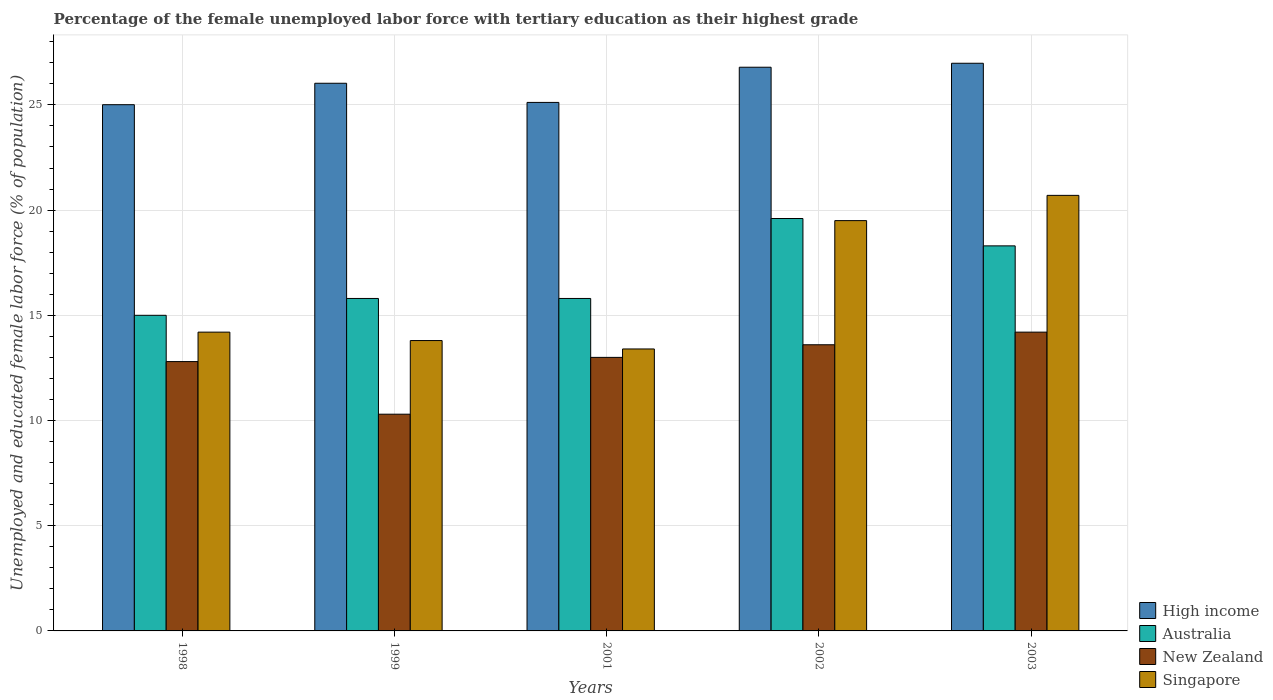Are the number of bars per tick equal to the number of legend labels?
Keep it short and to the point. Yes. Are the number of bars on each tick of the X-axis equal?
Make the answer very short. Yes. What is the label of the 2nd group of bars from the left?
Offer a very short reply. 1999. What is the percentage of the unemployed female labor force with tertiary education in New Zealand in 2003?
Offer a terse response. 14.2. Across all years, what is the maximum percentage of the unemployed female labor force with tertiary education in Australia?
Provide a succinct answer. 19.6. Across all years, what is the minimum percentage of the unemployed female labor force with tertiary education in Singapore?
Offer a terse response. 13.4. What is the total percentage of the unemployed female labor force with tertiary education in Australia in the graph?
Keep it short and to the point. 84.5. What is the difference between the percentage of the unemployed female labor force with tertiary education in Singapore in 2002 and that in 2003?
Provide a short and direct response. -1.2. What is the difference between the percentage of the unemployed female labor force with tertiary education in Singapore in 1998 and the percentage of the unemployed female labor force with tertiary education in High income in 2001?
Your answer should be very brief. -10.92. What is the average percentage of the unemployed female labor force with tertiary education in High income per year?
Offer a very short reply. 25.98. In the year 1998, what is the difference between the percentage of the unemployed female labor force with tertiary education in High income and percentage of the unemployed female labor force with tertiary education in Australia?
Offer a very short reply. 10.01. What is the ratio of the percentage of the unemployed female labor force with tertiary education in Singapore in 1998 to that in 2001?
Keep it short and to the point. 1.06. What is the difference between the highest and the second highest percentage of the unemployed female labor force with tertiary education in Singapore?
Give a very brief answer. 1.2. What is the difference between the highest and the lowest percentage of the unemployed female labor force with tertiary education in High income?
Ensure brevity in your answer.  1.97. What does the 1st bar from the left in 2001 represents?
Your response must be concise. High income. What does the 1st bar from the right in 1999 represents?
Provide a short and direct response. Singapore. Are all the bars in the graph horizontal?
Your response must be concise. No. Does the graph contain any zero values?
Give a very brief answer. No. Where does the legend appear in the graph?
Provide a short and direct response. Bottom right. What is the title of the graph?
Offer a terse response. Percentage of the female unemployed labor force with tertiary education as their highest grade. What is the label or title of the Y-axis?
Provide a short and direct response. Unemployed and educated female labor force (% of population). What is the Unemployed and educated female labor force (% of population) of High income in 1998?
Provide a succinct answer. 25.01. What is the Unemployed and educated female labor force (% of population) in Australia in 1998?
Offer a very short reply. 15. What is the Unemployed and educated female labor force (% of population) of New Zealand in 1998?
Offer a terse response. 12.8. What is the Unemployed and educated female labor force (% of population) of Singapore in 1998?
Give a very brief answer. 14.2. What is the Unemployed and educated female labor force (% of population) in High income in 1999?
Offer a very short reply. 26.03. What is the Unemployed and educated female labor force (% of population) of Australia in 1999?
Provide a succinct answer. 15.8. What is the Unemployed and educated female labor force (% of population) of New Zealand in 1999?
Provide a succinct answer. 10.3. What is the Unemployed and educated female labor force (% of population) of Singapore in 1999?
Give a very brief answer. 13.8. What is the Unemployed and educated female labor force (% of population) of High income in 2001?
Your answer should be compact. 25.12. What is the Unemployed and educated female labor force (% of population) in Australia in 2001?
Give a very brief answer. 15.8. What is the Unemployed and educated female labor force (% of population) in New Zealand in 2001?
Your answer should be very brief. 13. What is the Unemployed and educated female labor force (% of population) of Singapore in 2001?
Keep it short and to the point. 13.4. What is the Unemployed and educated female labor force (% of population) in High income in 2002?
Your answer should be very brief. 26.79. What is the Unemployed and educated female labor force (% of population) in Australia in 2002?
Your answer should be very brief. 19.6. What is the Unemployed and educated female labor force (% of population) in New Zealand in 2002?
Provide a short and direct response. 13.6. What is the Unemployed and educated female labor force (% of population) of Singapore in 2002?
Give a very brief answer. 19.5. What is the Unemployed and educated female labor force (% of population) in High income in 2003?
Give a very brief answer. 26.98. What is the Unemployed and educated female labor force (% of population) of Australia in 2003?
Provide a succinct answer. 18.3. What is the Unemployed and educated female labor force (% of population) of New Zealand in 2003?
Give a very brief answer. 14.2. What is the Unemployed and educated female labor force (% of population) in Singapore in 2003?
Your answer should be compact. 20.7. Across all years, what is the maximum Unemployed and educated female labor force (% of population) in High income?
Your response must be concise. 26.98. Across all years, what is the maximum Unemployed and educated female labor force (% of population) of Australia?
Provide a short and direct response. 19.6. Across all years, what is the maximum Unemployed and educated female labor force (% of population) in New Zealand?
Ensure brevity in your answer.  14.2. Across all years, what is the maximum Unemployed and educated female labor force (% of population) of Singapore?
Give a very brief answer. 20.7. Across all years, what is the minimum Unemployed and educated female labor force (% of population) of High income?
Your answer should be compact. 25.01. Across all years, what is the minimum Unemployed and educated female labor force (% of population) in Australia?
Offer a terse response. 15. Across all years, what is the minimum Unemployed and educated female labor force (% of population) in New Zealand?
Keep it short and to the point. 10.3. Across all years, what is the minimum Unemployed and educated female labor force (% of population) of Singapore?
Provide a succinct answer. 13.4. What is the total Unemployed and educated female labor force (% of population) in High income in the graph?
Provide a succinct answer. 129.92. What is the total Unemployed and educated female labor force (% of population) in Australia in the graph?
Provide a succinct answer. 84.5. What is the total Unemployed and educated female labor force (% of population) of New Zealand in the graph?
Provide a short and direct response. 63.9. What is the total Unemployed and educated female labor force (% of population) in Singapore in the graph?
Provide a short and direct response. 81.6. What is the difference between the Unemployed and educated female labor force (% of population) of High income in 1998 and that in 1999?
Offer a terse response. -1.02. What is the difference between the Unemployed and educated female labor force (% of population) of Australia in 1998 and that in 1999?
Give a very brief answer. -0.8. What is the difference between the Unemployed and educated female labor force (% of population) of New Zealand in 1998 and that in 1999?
Provide a short and direct response. 2.5. What is the difference between the Unemployed and educated female labor force (% of population) in Singapore in 1998 and that in 1999?
Your answer should be very brief. 0.4. What is the difference between the Unemployed and educated female labor force (% of population) of High income in 1998 and that in 2001?
Your response must be concise. -0.11. What is the difference between the Unemployed and educated female labor force (% of population) of Australia in 1998 and that in 2001?
Keep it short and to the point. -0.8. What is the difference between the Unemployed and educated female labor force (% of population) of New Zealand in 1998 and that in 2001?
Provide a succinct answer. -0.2. What is the difference between the Unemployed and educated female labor force (% of population) in Singapore in 1998 and that in 2001?
Offer a terse response. 0.8. What is the difference between the Unemployed and educated female labor force (% of population) in High income in 1998 and that in 2002?
Your answer should be compact. -1.78. What is the difference between the Unemployed and educated female labor force (% of population) of High income in 1998 and that in 2003?
Provide a short and direct response. -1.97. What is the difference between the Unemployed and educated female labor force (% of population) of Australia in 1998 and that in 2003?
Ensure brevity in your answer.  -3.3. What is the difference between the Unemployed and educated female labor force (% of population) in Singapore in 1998 and that in 2003?
Provide a succinct answer. -6.5. What is the difference between the Unemployed and educated female labor force (% of population) in High income in 1999 and that in 2001?
Give a very brief answer. 0.91. What is the difference between the Unemployed and educated female labor force (% of population) of High income in 1999 and that in 2002?
Offer a very short reply. -0.76. What is the difference between the Unemployed and educated female labor force (% of population) of Australia in 1999 and that in 2002?
Offer a terse response. -3.8. What is the difference between the Unemployed and educated female labor force (% of population) of Singapore in 1999 and that in 2002?
Provide a succinct answer. -5.7. What is the difference between the Unemployed and educated female labor force (% of population) in High income in 1999 and that in 2003?
Your response must be concise. -0.95. What is the difference between the Unemployed and educated female labor force (% of population) of Australia in 1999 and that in 2003?
Give a very brief answer. -2.5. What is the difference between the Unemployed and educated female labor force (% of population) in New Zealand in 1999 and that in 2003?
Provide a succinct answer. -3.9. What is the difference between the Unemployed and educated female labor force (% of population) in Singapore in 1999 and that in 2003?
Your answer should be compact. -6.9. What is the difference between the Unemployed and educated female labor force (% of population) of High income in 2001 and that in 2002?
Make the answer very short. -1.67. What is the difference between the Unemployed and educated female labor force (% of population) in Australia in 2001 and that in 2002?
Your response must be concise. -3.8. What is the difference between the Unemployed and educated female labor force (% of population) in New Zealand in 2001 and that in 2002?
Give a very brief answer. -0.6. What is the difference between the Unemployed and educated female labor force (% of population) of High income in 2001 and that in 2003?
Your answer should be compact. -1.86. What is the difference between the Unemployed and educated female labor force (% of population) of Australia in 2001 and that in 2003?
Offer a very short reply. -2.5. What is the difference between the Unemployed and educated female labor force (% of population) of New Zealand in 2001 and that in 2003?
Your answer should be very brief. -1.2. What is the difference between the Unemployed and educated female labor force (% of population) of High income in 2002 and that in 2003?
Make the answer very short. -0.19. What is the difference between the Unemployed and educated female labor force (% of population) of Australia in 2002 and that in 2003?
Make the answer very short. 1.3. What is the difference between the Unemployed and educated female labor force (% of population) of New Zealand in 2002 and that in 2003?
Offer a terse response. -0.6. What is the difference between the Unemployed and educated female labor force (% of population) in High income in 1998 and the Unemployed and educated female labor force (% of population) in Australia in 1999?
Your answer should be compact. 9.21. What is the difference between the Unemployed and educated female labor force (% of population) of High income in 1998 and the Unemployed and educated female labor force (% of population) of New Zealand in 1999?
Ensure brevity in your answer.  14.71. What is the difference between the Unemployed and educated female labor force (% of population) in High income in 1998 and the Unemployed and educated female labor force (% of population) in Singapore in 1999?
Provide a succinct answer. 11.21. What is the difference between the Unemployed and educated female labor force (% of population) in High income in 1998 and the Unemployed and educated female labor force (% of population) in Australia in 2001?
Offer a terse response. 9.21. What is the difference between the Unemployed and educated female labor force (% of population) in High income in 1998 and the Unemployed and educated female labor force (% of population) in New Zealand in 2001?
Make the answer very short. 12.01. What is the difference between the Unemployed and educated female labor force (% of population) in High income in 1998 and the Unemployed and educated female labor force (% of population) in Singapore in 2001?
Your answer should be compact. 11.61. What is the difference between the Unemployed and educated female labor force (% of population) of Australia in 1998 and the Unemployed and educated female labor force (% of population) of Singapore in 2001?
Your answer should be compact. 1.6. What is the difference between the Unemployed and educated female labor force (% of population) of High income in 1998 and the Unemployed and educated female labor force (% of population) of Australia in 2002?
Give a very brief answer. 5.41. What is the difference between the Unemployed and educated female labor force (% of population) of High income in 1998 and the Unemployed and educated female labor force (% of population) of New Zealand in 2002?
Offer a very short reply. 11.41. What is the difference between the Unemployed and educated female labor force (% of population) in High income in 1998 and the Unemployed and educated female labor force (% of population) in Singapore in 2002?
Provide a short and direct response. 5.51. What is the difference between the Unemployed and educated female labor force (% of population) of Australia in 1998 and the Unemployed and educated female labor force (% of population) of New Zealand in 2002?
Provide a short and direct response. 1.4. What is the difference between the Unemployed and educated female labor force (% of population) of New Zealand in 1998 and the Unemployed and educated female labor force (% of population) of Singapore in 2002?
Your response must be concise. -6.7. What is the difference between the Unemployed and educated female labor force (% of population) of High income in 1998 and the Unemployed and educated female labor force (% of population) of Australia in 2003?
Offer a terse response. 6.71. What is the difference between the Unemployed and educated female labor force (% of population) of High income in 1998 and the Unemployed and educated female labor force (% of population) of New Zealand in 2003?
Offer a terse response. 10.81. What is the difference between the Unemployed and educated female labor force (% of population) in High income in 1998 and the Unemployed and educated female labor force (% of population) in Singapore in 2003?
Your answer should be very brief. 4.31. What is the difference between the Unemployed and educated female labor force (% of population) of Australia in 1998 and the Unemployed and educated female labor force (% of population) of New Zealand in 2003?
Offer a very short reply. 0.8. What is the difference between the Unemployed and educated female labor force (% of population) of High income in 1999 and the Unemployed and educated female labor force (% of population) of Australia in 2001?
Keep it short and to the point. 10.23. What is the difference between the Unemployed and educated female labor force (% of population) in High income in 1999 and the Unemployed and educated female labor force (% of population) in New Zealand in 2001?
Provide a short and direct response. 13.03. What is the difference between the Unemployed and educated female labor force (% of population) of High income in 1999 and the Unemployed and educated female labor force (% of population) of Singapore in 2001?
Give a very brief answer. 12.63. What is the difference between the Unemployed and educated female labor force (% of population) of Australia in 1999 and the Unemployed and educated female labor force (% of population) of Singapore in 2001?
Your answer should be very brief. 2.4. What is the difference between the Unemployed and educated female labor force (% of population) of High income in 1999 and the Unemployed and educated female labor force (% of population) of Australia in 2002?
Your answer should be very brief. 6.43. What is the difference between the Unemployed and educated female labor force (% of population) of High income in 1999 and the Unemployed and educated female labor force (% of population) of New Zealand in 2002?
Give a very brief answer. 12.43. What is the difference between the Unemployed and educated female labor force (% of population) of High income in 1999 and the Unemployed and educated female labor force (% of population) of Singapore in 2002?
Provide a short and direct response. 6.53. What is the difference between the Unemployed and educated female labor force (% of population) of Australia in 1999 and the Unemployed and educated female labor force (% of population) of New Zealand in 2002?
Offer a very short reply. 2.2. What is the difference between the Unemployed and educated female labor force (% of population) in Australia in 1999 and the Unemployed and educated female labor force (% of population) in Singapore in 2002?
Provide a short and direct response. -3.7. What is the difference between the Unemployed and educated female labor force (% of population) of New Zealand in 1999 and the Unemployed and educated female labor force (% of population) of Singapore in 2002?
Your answer should be compact. -9.2. What is the difference between the Unemployed and educated female labor force (% of population) of High income in 1999 and the Unemployed and educated female labor force (% of population) of Australia in 2003?
Provide a short and direct response. 7.73. What is the difference between the Unemployed and educated female labor force (% of population) in High income in 1999 and the Unemployed and educated female labor force (% of population) in New Zealand in 2003?
Make the answer very short. 11.83. What is the difference between the Unemployed and educated female labor force (% of population) of High income in 1999 and the Unemployed and educated female labor force (% of population) of Singapore in 2003?
Your response must be concise. 5.33. What is the difference between the Unemployed and educated female labor force (% of population) in High income in 2001 and the Unemployed and educated female labor force (% of population) in Australia in 2002?
Your response must be concise. 5.52. What is the difference between the Unemployed and educated female labor force (% of population) of High income in 2001 and the Unemployed and educated female labor force (% of population) of New Zealand in 2002?
Offer a terse response. 11.52. What is the difference between the Unemployed and educated female labor force (% of population) of High income in 2001 and the Unemployed and educated female labor force (% of population) of Singapore in 2002?
Provide a short and direct response. 5.62. What is the difference between the Unemployed and educated female labor force (% of population) of Australia in 2001 and the Unemployed and educated female labor force (% of population) of New Zealand in 2002?
Offer a terse response. 2.2. What is the difference between the Unemployed and educated female labor force (% of population) in Australia in 2001 and the Unemployed and educated female labor force (% of population) in Singapore in 2002?
Your answer should be compact. -3.7. What is the difference between the Unemployed and educated female labor force (% of population) in High income in 2001 and the Unemployed and educated female labor force (% of population) in Australia in 2003?
Provide a short and direct response. 6.82. What is the difference between the Unemployed and educated female labor force (% of population) in High income in 2001 and the Unemployed and educated female labor force (% of population) in New Zealand in 2003?
Offer a terse response. 10.92. What is the difference between the Unemployed and educated female labor force (% of population) in High income in 2001 and the Unemployed and educated female labor force (% of population) in Singapore in 2003?
Give a very brief answer. 4.42. What is the difference between the Unemployed and educated female labor force (% of population) in High income in 2002 and the Unemployed and educated female labor force (% of population) in Australia in 2003?
Your response must be concise. 8.49. What is the difference between the Unemployed and educated female labor force (% of population) of High income in 2002 and the Unemployed and educated female labor force (% of population) of New Zealand in 2003?
Your response must be concise. 12.59. What is the difference between the Unemployed and educated female labor force (% of population) of High income in 2002 and the Unemployed and educated female labor force (% of population) of Singapore in 2003?
Offer a very short reply. 6.09. What is the difference between the Unemployed and educated female labor force (% of population) of Australia in 2002 and the Unemployed and educated female labor force (% of population) of New Zealand in 2003?
Provide a succinct answer. 5.4. What is the difference between the Unemployed and educated female labor force (% of population) in Australia in 2002 and the Unemployed and educated female labor force (% of population) in Singapore in 2003?
Make the answer very short. -1.1. What is the average Unemployed and educated female labor force (% of population) of High income per year?
Your response must be concise. 25.98. What is the average Unemployed and educated female labor force (% of population) in Australia per year?
Ensure brevity in your answer.  16.9. What is the average Unemployed and educated female labor force (% of population) of New Zealand per year?
Provide a succinct answer. 12.78. What is the average Unemployed and educated female labor force (% of population) in Singapore per year?
Provide a short and direct response. 16.32. In the year 1998, what is the difference between the Unemployed and educated female labor force (% of population) in High income and Unemployed and educated female labor force (% of population) in Australia?
Your answer should be very brief. 10.01. In the year 1998, what is the difference between the Unemployed and educated female labor force (% of population) in High income and Unemployed and educated female labor force (% of population) in New Zealand?
Provide a succinct answer. 12.21. In the year 1998, what is the difference between the Unemployed and educated female labor force (% of population) in High income and Unemployed and educated female labor force (% of population) in Singapore?
Keep it short and to the point. 10.81. In the year 1998, what is the difference between the Unemployed and educated female labor force (% of population) in Australia and Unemployed and educated female labor force (% of population) in New Zealand?
Your answer should be very brief. 2.2. In the year 1998, what is the difference between the Unemployed and educated female labor force (% of population) of Australia and Unemployed and educated female labor force (% of population) of Singapore?
Provide a short and direct response. 0.8. In the year 1998, what is the difference between the Unemployed and educated female labor force (% of population) in New Zealand and Unemployed and educated female labor force (% of population) in Singapore?
Give a very brief answer. -1.4. In the year 1999, what is the difference between the Unemployed and educated female labor force (% of population) in High income and Unemployed and educated female labor force (% of population) in Australia?
Provide a succinct answer. 10.23. In the year 1999, what is the difference between the Unemployed and educated female labor force (% of population) of High income and Unemployed and educated female labor force (% of population) of New Zealand?
Offer a very short reply. 15.73. In the year 1999, what is the difference between the Unemployed and educated female labor force (% of population) in High income and Unemployed and educated female labor force (% of population) in Singapore?
Give a very brief answer. 12.23. In the year 1999, what is the difference between the Unemployed and educated female labor force (% of population) of Australia and Unemployed and educated female labor force (% of population) of New Zealand?
Offer a very short reply. 5.5. In the year 1999, what is the difference between the Unemployed and educated female labor force (% of population) of New Zealand and Unemployed and educated female labor force (% of population) of Singapore?
Your answer should be very brief. -3.5. In the year 2001, what is the difference between the Unemployed and educated female labor force (% of population) in High income and Unemployed and educated female labor force (% of population) in Australia?
Offer a terse response. 9.32. In the year 2001, what is the difference between the Unemployed and educated female labor force (% of population) of High income and Unemployed and educated female labor force (% of population) of New Zealand?
Give a very brief answer. 12.12. In the year 2001, what is the difference between the Unemployed and educated female labor force (% of population) of High income and Unemployed and educated female labor force (% of population) of Singapore?
Provide a succinct answer. 11.72. In the year 2001, what is the difference between the Unemployed and educated female labor force (% of population) of Australia and Unemployed and educated female labor force (% of population) of Singapore?
Your answer should be very brief. 2.4. In the year 2002, what is the difference between the Unemployed and educated female labor force (% of population) in High income and Unemployed and educated female labor force (% of population) in Australia?
Keep it short and to the point. 7.19. In the year 2002, what is the difference between the Unemployed and educated female labor force (% of population) in High income and Unemployed and educated female labor force (% of population) in New Zealand?
Ensure brevity in your answer.  13.19. In the year 2002, what is the difference between the Unemployed and educated female labor force (% of population) of High income and Unemployed and educated female labor force (% of population) of Singapore?
Ensure brevity in your answer.  7.29. In the year 2002, what is the difference between the Unemployed and educated female labor force (% of population) in New Zealand and Unemployed and educated female labor force (% of population) in Singapore?
Offer a very short reply. -5.9. In the year 2003, what is the difference between the Unemployed and educated female labor force (% of population) of High income and Unemployed and educated female labor force (% of population) of Australia?
Provide a short and direct response. 8.68. In the year 2003, what is the difference between the Unemployed and educated female labor force (% of population) in High income and Unemployed and educated female labor force (% of population) in New Zealand?
Your answer should be very brief. 12.78. In the year 2003, what is the difference between the Unemployed and educated female labor force (% of population) of High income and Unemployed and educated female labor force (% of population) of Singapore?
Offer a very short reply. 6.28. In the year 2003, what is the difference between the Unemployed and educated female labor force (% of population) in Australia and Unemployed and educated female labor force (% of population) in Singapore?
Provide a short and direct response. -2.4. What is the ratio of the Unemployed and educated female labor force (% of population) in High income in 1998 to that in 1999?
Your response must be concise. 0.96. What is the ratio of the Unemployed and educated female labor force (% of population) in Australia in 1998 to that in 1999?
Your answer should be very brief. 0.95. What is the ratio of the Unemployed and educated female labor force (% of population) in New Zealand in 1998 to that in 1999?
Your response must be concise. 1.24. What is the ratio of the Unemployed and educated female labor force (% of population) of Australia in 1998 to that in 2001?
Your answer should be very brief. 0.95. What is the ratio of the Unemployed and educated female labor force (% of population) in New Zealand in 1998 to that in 2001?
Your answer should be compact. 0.98. What is the ratio of the Unemployed and educated female labor force (% of population) in Singapore in 1998 to that in 2001?
Keep it short and to the point. 1.06. What is the ratio of the Unemployed and educated female labor force (% of population) in High income in 1998 to that in 2002?
Provide a short and direct response. 0.93. What is the ratio of the Unemployed and educated female labor force (% of population) of Australia in 1998 to that in 2002?
Provide a succinct answer. 0.77. What is the ratio of the Unemployed and educated female labor force (% of population) in New Zealand in 1998 to that in 2002?
Give a very brief answer. 0.94. What is the ratio of the Unemployed and educated female labor force (% of population) in Singapore in 1998 to that in 2002?
Provide a succinct answer. 0.73. What is the ratio of the Unemployed and educated female labor force (% of population) of High income in 1998 to that in 2003?
Give a very brief answer. 0.93. What is the ratio of the Unemployed and educated female labor force (% of population) of Australia in 1998 to that in 2003?
Provide a short and direct response. 0.82. What is the ratio of the Unemployed and educated female labor force (% of population) in New Zealand in 1998 to that in 2003?
Your answer should be very brief. 0.9. What is the ratio of the Unemployed and educated female labor force (% of population) of Singapore in 1998 to that in 2003?
Make the answer very short. 0.69. What is the ratio of the Unemployed and educated female labor force (% of population) of High income in 1999 to that in 2001?
Offer a terse response. 1.04. What is the ratio of the Unemployed and educated female labor force (% of population) in Australia in 1999 to that in 2001?
Make the answer very short. 1. What is the ratio of the Unemployed and educated female labor force (% of population) of New Zealand in 1999 to that in 2001?
Your response must be concise. 0.79. What is the ratio of the Unemployed and educated female labor force (% of population) of Singapore in 1999 to that in 2001?
Ensure brevity in your answer.  1.03. What is the ratio of the Unemployed and educated female labor force (% of population) of High income in 1999 to that in 2002?
Ensure brevity in your answer.  0.97. What is the ratio of the Unemployed and educated female labor force (% of population) of Australia in 1999 to that in 2002?
Give a very brief answer. 0.81. What is the ratio of the Unemployed and educated female labor force (% of population) of New Zealand in 1999 to that in 2002?
Provide a succinct answer. 0.76. What is the ratio of the Unemployed and educated female labor force (% of population) in Singapore in 1999 to that in 2002?
Make the answer very short. 0.71. What is the ratio of the Unemployed and educated female labor force (% of population) in High income in 1999 to that in 2003?
Ensure brevity in your answer.  0.96. What is the ratio of the Unemployed and educated female labor force (% of population) of Australia in 1999 to that in 2003?
Your response must be concise. 0.86. What is the ratio of the Unemployed and educated female labor force (% of population) of New Zealand in 1999 to that in 2003?
Offer a very short reply. 0.73. What is the ratio of the Unemployed and educated female labor force (% of population) in Singapore in 1999 to that in 2003?
Keep it short and to the point. 0.67. What is the ratio of the Unemployed and educated female labor force (% of population) of High income in 2001 to that in 2002?
Make the answer very short. 0.94. What is the ratio of the Unemployed and educated female labor force (% of population) in Australia in 2001 to that in 2002?
Your answer should be compact. 0.81. What is the ratio of the Unemployed and educated female labor force (% of population) of New Zealand in 2001 to that in 2002?
Your answer should be compact. 0.96. What is the ratio of the Unemployed and educated female labor force (% of population) in Singapore in 2001 to that in 2002?
Your answer should be very brief. 0.69. What is the ratio of the Unemployed and educated female labor force (% of population) in High income in 2001 to that in 2003?
Make the answer very short. 0.93. What is the ratio of the Unemployed and educated female labor force (% of population) in Australia in 2001 to that in 2003?
Your response must be concise. 0.86. What is the ratio of the Unemployed and educated female labor force (% of population) in New Zealand in 2001 to that in 2003?
Offer a terse response. 0.92. What is the ratio of the Unemployed and educated female labor force (% of population) of Singapore in 2001 to that in 2003?
Make the answer very short. 0.65. What is the ratio of the Unemployed and educated female labor force (% of population) of Australia in 2002 to that in 2003?
Provide a short and direct response. 1.07. What is the ratio of the Unemployed and educated female labor force (% of population) in New Zealand in 2002 to that in 2003?
Make the answer very short. 0.96. What is the ratio of the Unemployed and educated female labor force (% of population) in Singapore in 2002 to that in 2003?
Provide a succinct answer. 0.94. What is the difference between the highest and the second highest Unemployed and educated female labor force (% of population) of High income?
Keep it short and to the point. 0.19. What is the difference between the highest and the second highest Unemployed and educated female labor force (% of population) in New Zealand?
Your answer should be very brief. 0.6. What is the difference between the highest and the second highest Unemployed and educated female labor force (% of population) in Singapore?
Your answer should be compact. 1.2. What is the difference between the highest and the lowest Unemployed and educated female labor force (% of population) of High income?
Provide a succinct answer. 1.97. What is the difference between the highest and the lowest Unemployed and educated female labor force (% of population) in New Zealand?
Provide a succinct answer. 3.9. What is the difference between the highest and the lowest Unemployed and educated female labor force (% of population) of Singapore?
Your response must be concise. 7.3. 